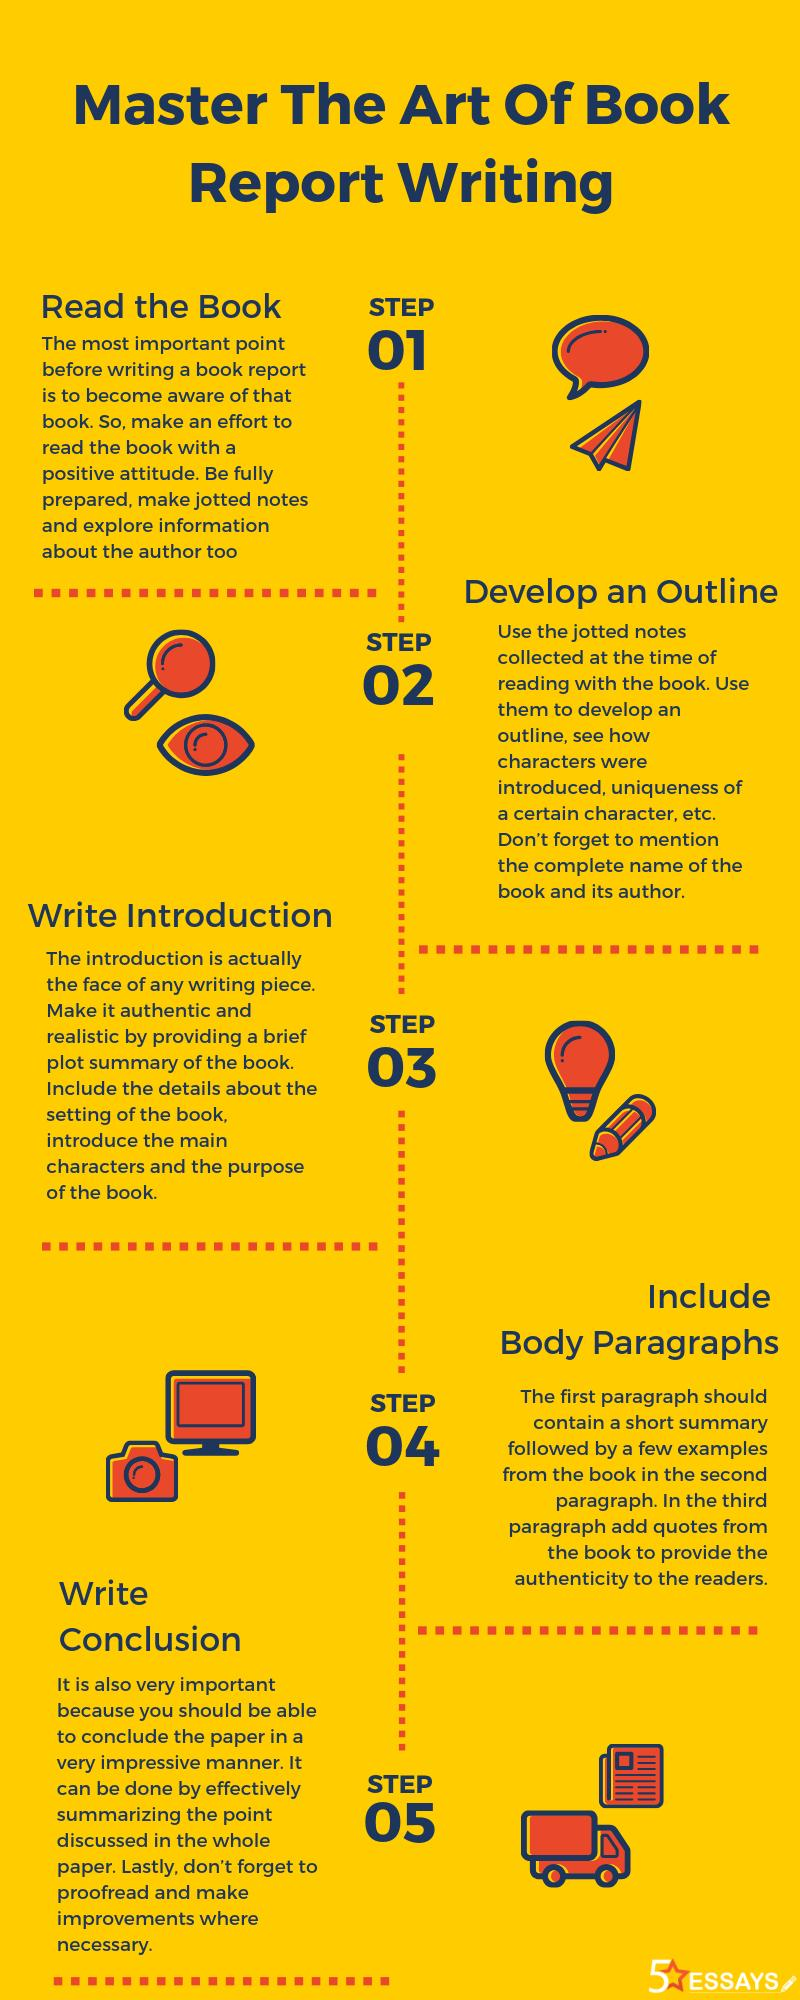Specify some key components in this picture. The third step in the infographic is to write an introduction. There is only one camera featured in this infographic. The fourth step in the infographic is the implementation of the system through a phased approach that is agreed upon by all stakeholders. The second step in the infographic is to develop an outline. 